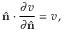<formula> <loc_0><loc_0><loc_500><loc_500>\hat { n } \cdot \frac { \partial v } { \partial \hat { n } } = v \, ,</formula> 